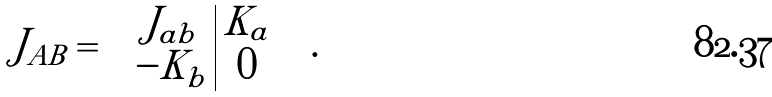<formula> <loc_0><loc_0><loc_500><loc_500>J _ { A B } = \left ( \begin{array} { c | c } J _ { a b } & K _ { a } \\ - K _ { b } & 0 \end{array} \right ) \, .</formula> 